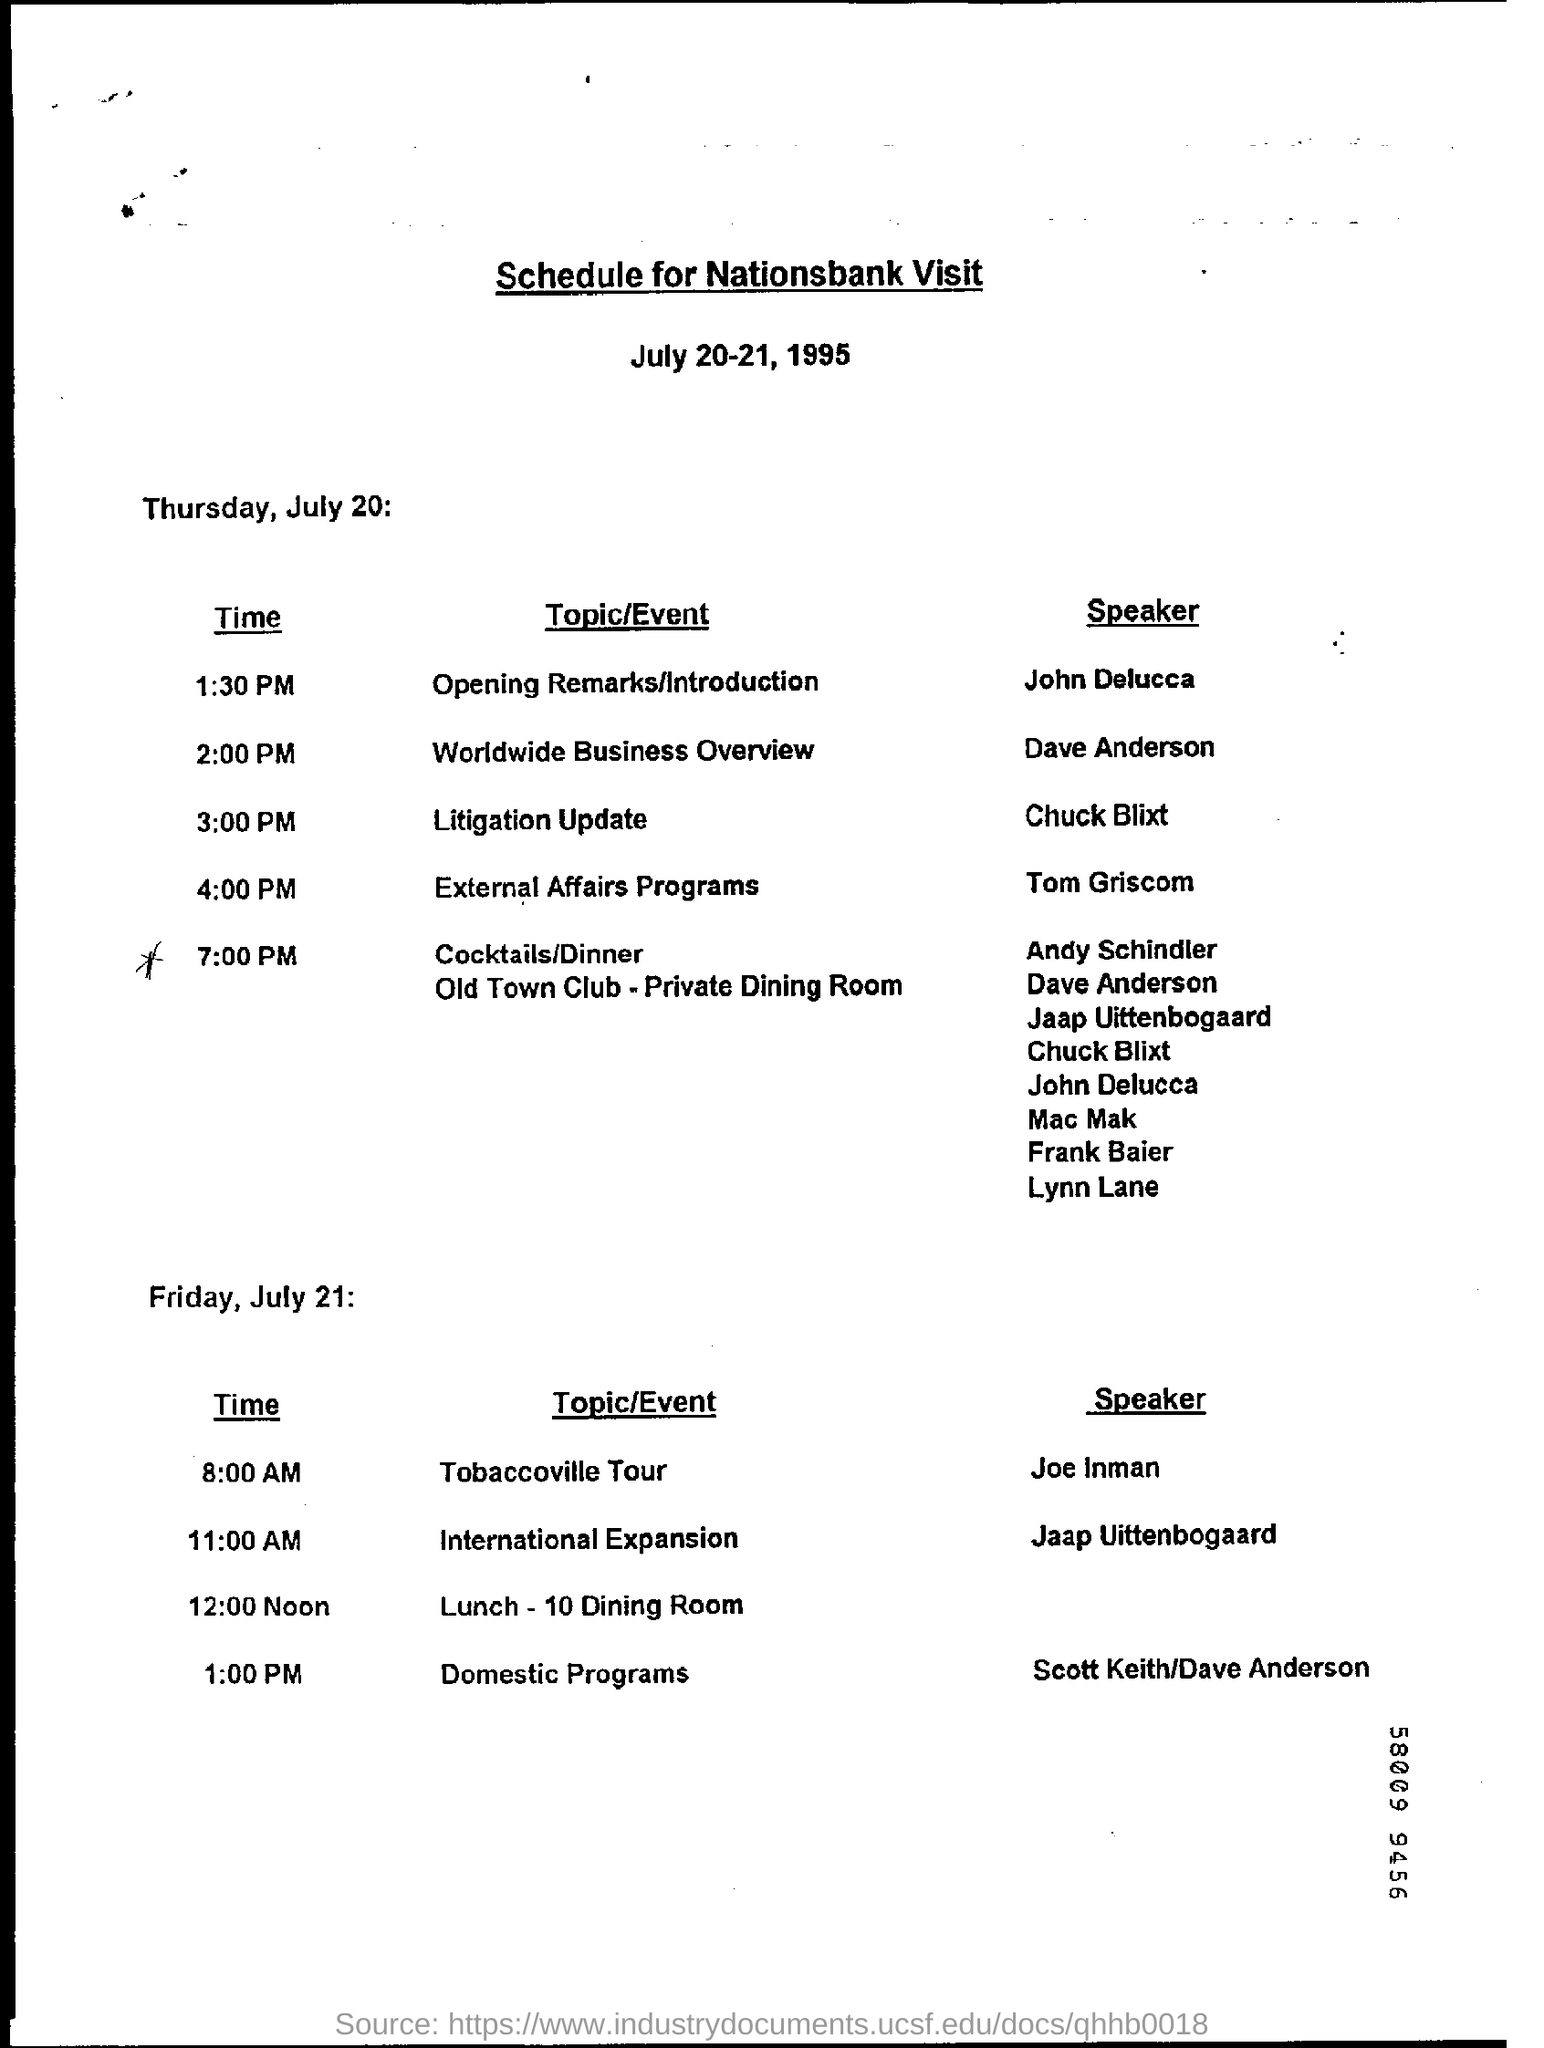Highlight a few significant elements in this photo. The dinner is scheduled for 7:00 PM. The speaker of the topic "Litigation Update" is Chuck Blixt. The topic of opening remarks/introduction will be handled at 1:30 PM. The speaker of the Tobaccoville Tour is Joe Inman. 